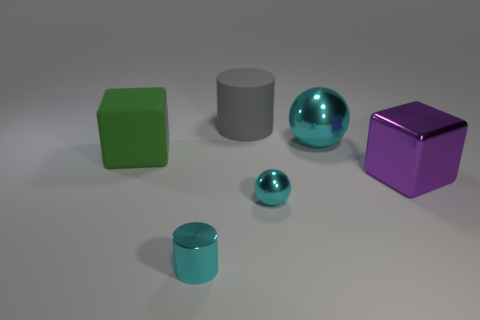What is the shape of the purple metal object that is the same size as the green matte object?
Provide a succinct answer. Cube. How many large gray rubber objects are on the right side of the rubber object that is to the right of the big block that is on the left side of the purple metallic block?
Make the answer very short. 0. What number of metal objects are either brown spheres or tiny cyan objects?
Offer a very short reply. 2. The large object that is both in front of the big cyan shiny ball and to the left of the metal block is what color?
Ensure brevity in your answer.  Green. Does the cyan metallic thing that is behind the purple cube have the same size as the cyan cylinder?
Ensure brevity in your answer.  No. How many objects are either large things that are to the left of the purple thing or tiny purple shiny objects?
Your answer should be compact. 3. Are there any shiny blocks of the same size as the gray thing?
Make the answer very short. Yes. There is a cyan thing that is the same size as the cyan metallic cylinder; what is its material?
Your answer should be compact. Metal. What is the shape of the large thing that is both on the right side of the shiny cylinder and to the left of the small metallic sphere?
Make the answer very short. Cylinder. The big rubber thing that is to the right of the small cyan metal cylinder is what color?
Offer a very short reply. Gray. 